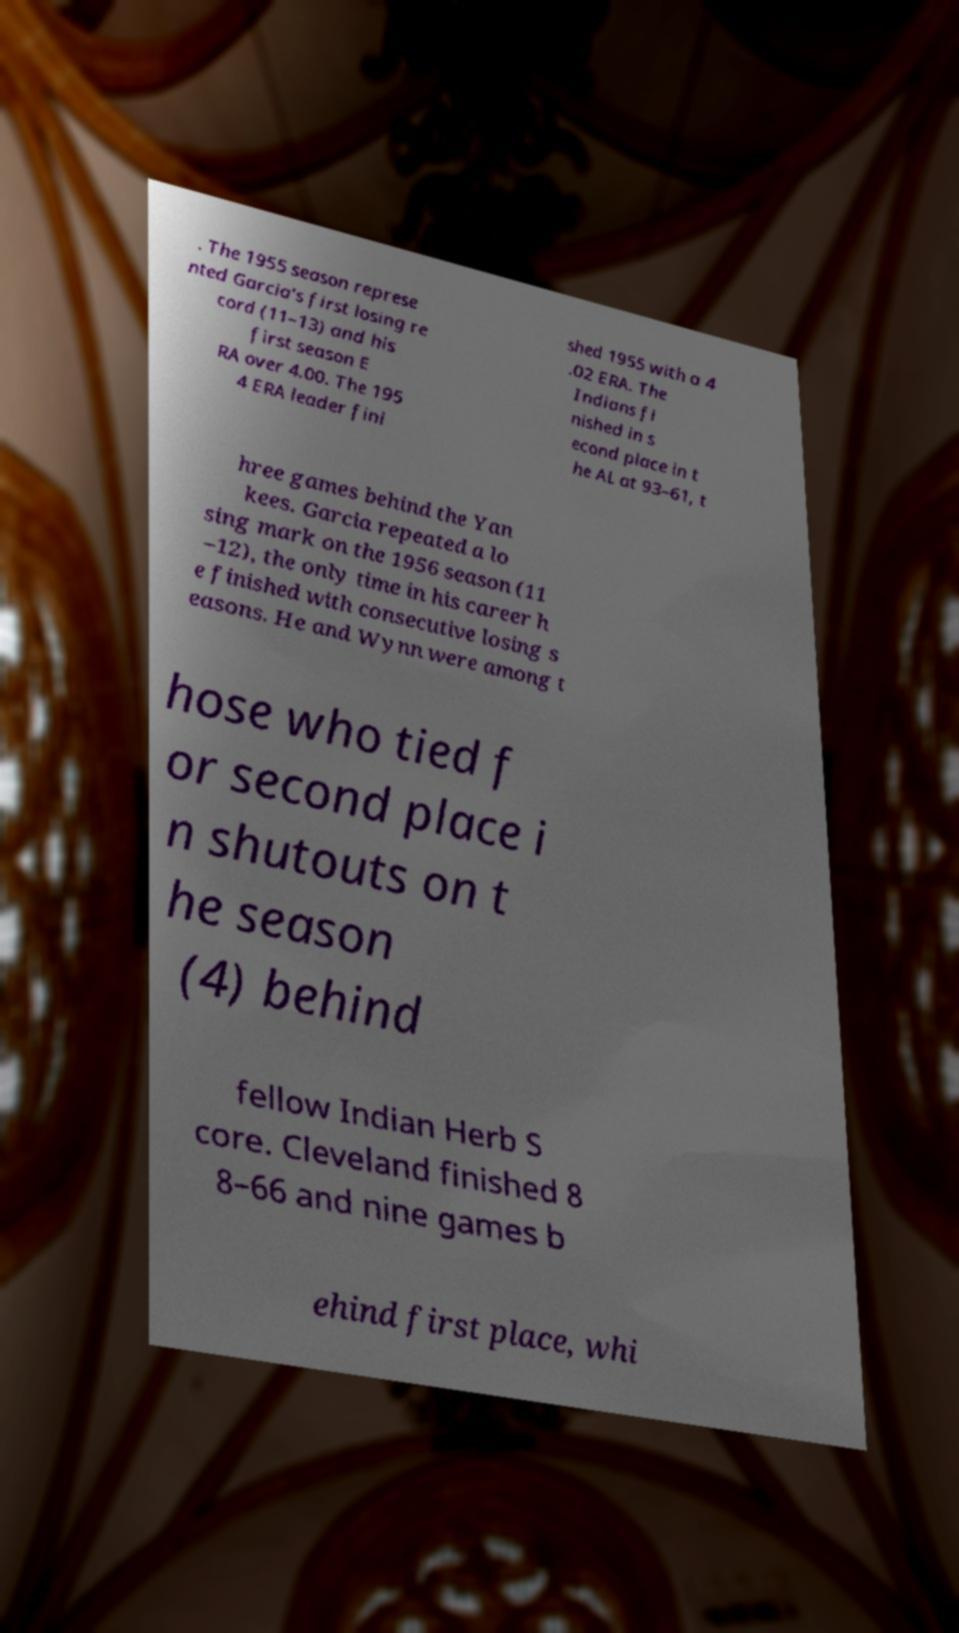Can you read and provide the text displayed in the image?This photo seems to have some interesting text. Can you extract and type it out for me? . The 1955 season represe nted Garcia's first losing re cord (11–13) and his first season E RA over 4.00. The 195 4 ERA leader fini shed 1955 with a 4 .02 ERA. The Indians fi nished in s econd place in t he AL at 93–61, t hree games behind the Yan kees. Garcia repeated a lo sing mark on the 1956 season (11 –12), the only time in his career h e finished with consecutive losing s easons. He and Wynn were among t hose who tied f or second place i n shutouts on t he season (4) behind fellow Indian Herb S core. Cleveland finished 8 8–66 and nine games b ehind first place, whi 